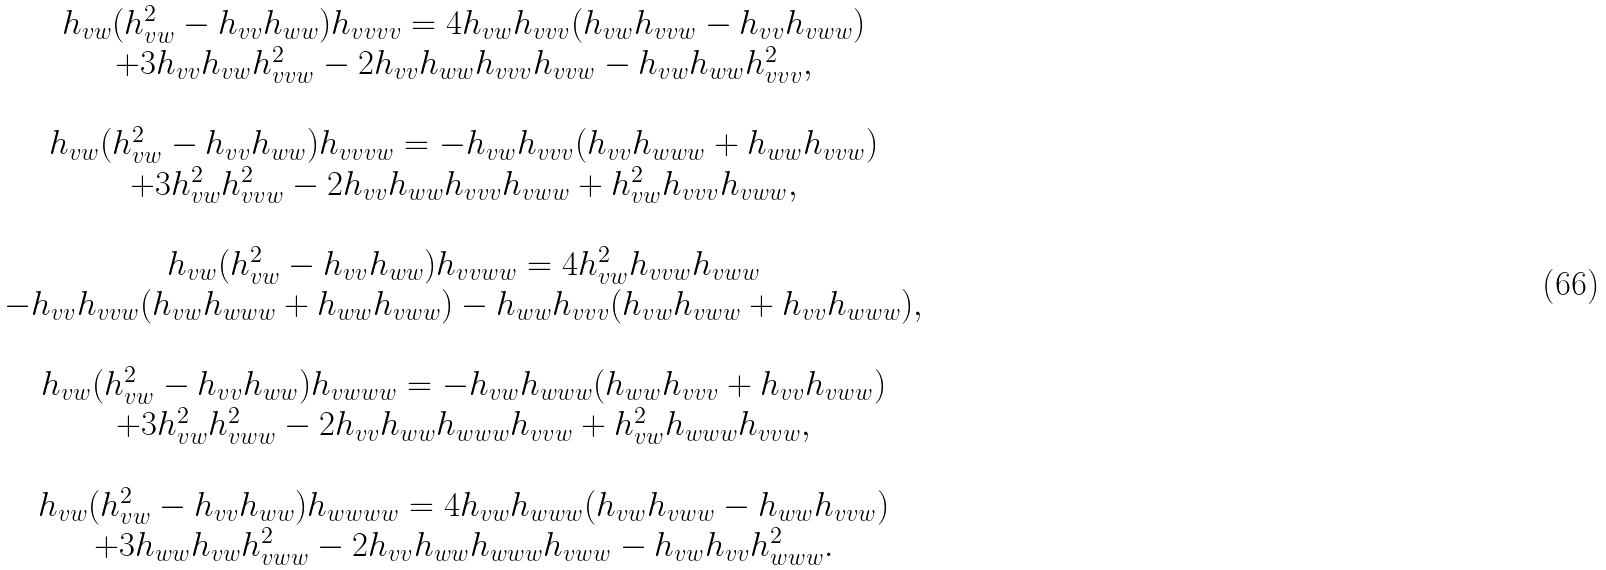<formula> <loc_0><loc_0><loc_500><loc_500>\begin{array} { c } h _ { v w } ( h _ { v w } ^ { 2 } - h _ { v v } h _ { w w } ) h _ { v v v v } = 4 h _ { v w } h _ { v v v } ( h _ { v w } h _ { v v w } - h _ { v v } h _ { v w w } ) \\ + 3 h _ { v v } h _ { v w } h ^ { 2 } _ { v v w } - 2 h _ { v v } h _ { w w } h _ { v v v } h _ { v v w } - h _ { v w } h _ { w w } h ^ { 2 } _ { v v v } , \\ \ \\ h _ { v w } ( h _ { v w } ^ { 2 } - h _ { v v } h _ { w w } ) h _ { v v v w } = - h _ { v w } h _ { v v v } ( h _ { v v } h _ { w w w } + h _ { w w } h _ { v v w } ) \\ + 3 h ^ { 2 } _ { v w } h ^ { 2 } _ { v v w } - 2 h _ { v v } h _ { w w } h _ { v v v } h _ { v w w } + h ^ { 2 } _ { v w } h _ { v v v } h _ { v w w } , \\ \ \\ h _ { v w } ( h _ { v w } ^ { 2 } - h _ { v v } h _ { w w } ) h _ { v v w w } = 4 h ^ { 2 } _ { v w } h _ { v v w } h _ { v w w } \\ - h _ { v v } h _ { v v w } ( h _ { v w } h _ { w w w } + h _ { w w } h _ { v w w } ) - h _ { w w } h _ { v v v } ( h _ { v w } h _ { v w w } + h _ { v v } h _ { w w w } ) , \\ \ \\ h _ { v w } ( h _ { v w } ^ { 2 } - h _ { v v } h _ { w w } ) h _ { v w w w } = - h _ { v w } h _ { w w w } ( h _ { w w } h _ { v v v } + h _ { v v } h _ { v w w } ) \\ + 3 h ^ { 2 } _ { v w } h ^ { 2 } _ { v w w } - 2 h _ { v v } h _ { w w } h _ { w w w } h _ { v v w } + h ^ { 2 } _ { v w } h _ { w w w } h _ { v v w } , \\ \ \\ h _ { v w } ( h _ { v w } ^ { 2 } - h _ { v v } h _ { w w } ) h _ { w w w w } = 4 h _ { v w } h _ { w w w } ( h _ { v w } h _ { v w w } - h _ { w w } h _ { v v w } ) \\ + 3 h _ { w w } h _ { v w } h ^ { 2 } _ { v w w } - 2 h _ { v v } h _ { w w } h _ { w w w } h _ { v w w } - h _ { v w } h _ { v v } h ^ { 2 } _ { w w w } . \\ \end{array}</formula> 